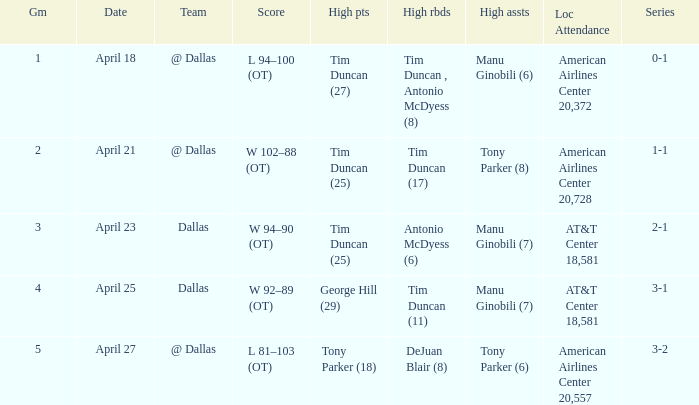When 5 is the game who has the highest amount of points? Tony Parker (18). 